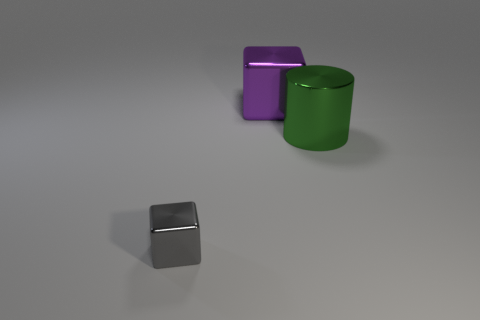Could you describe the colors and materials of the objects shown? Certainly! The image displays three objects with distinct colors and a matte finish. There's a small gray cube with a reflective surface, suggesting a metallic material. Then there's a larger purple cube with a less reflective surface, perhaps plastic. Finally, we see a green cylinder, also with a matte finish, likely made of a similar plastic material. 